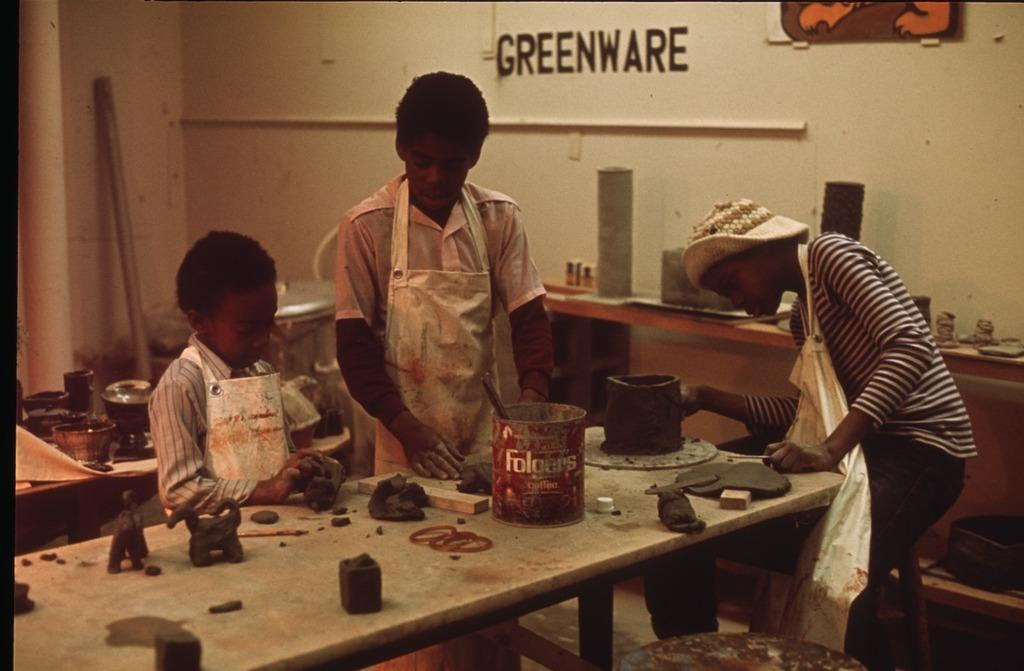What is happening in the image involving the kids? The kids are making idols with clay on a table. What material are the kids using to create their idols? The kids are using clay to create their idols. What word is written on the wall in the image? The word "greenware" is written on the wall. What type of location does the image appear to depict? The setting appears to be a foundry lab. What type of lip gloss is being used by the kids in the image? There is no lip gloss present in the image; the kids are making idols with clay on a table. What type of copper material is being used by the kids in the image? There is no copper material present in the image; the kids are using clay to create their idols. 